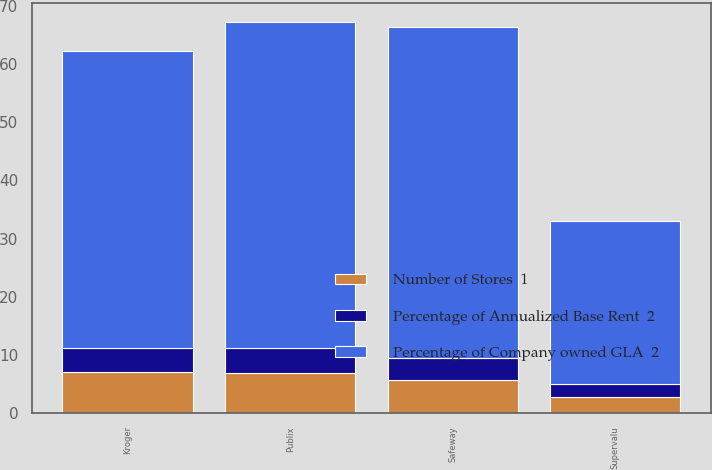<chart> <loc_0><loc_0><loc_500><loc_500><stacked_bar_chart><ecel><fcel>Kroger<fcel>Publix<fcel>Safeway<fcel>Supervalu<nl><fcel>Percentage of Company owned GLA  2<fcel>51<fcel>56<fcel>57<fcel>28<nl><fcel>Number of Stores  1<fcel>7<fcel>6.8<fcel>5.7<fcel>2.8<nl><fcel>Percentage of Annualized Base Rent  2<fcel>4.2<fcel>4.4<fcel>3.7<fcel>2.2<nl></chart> 